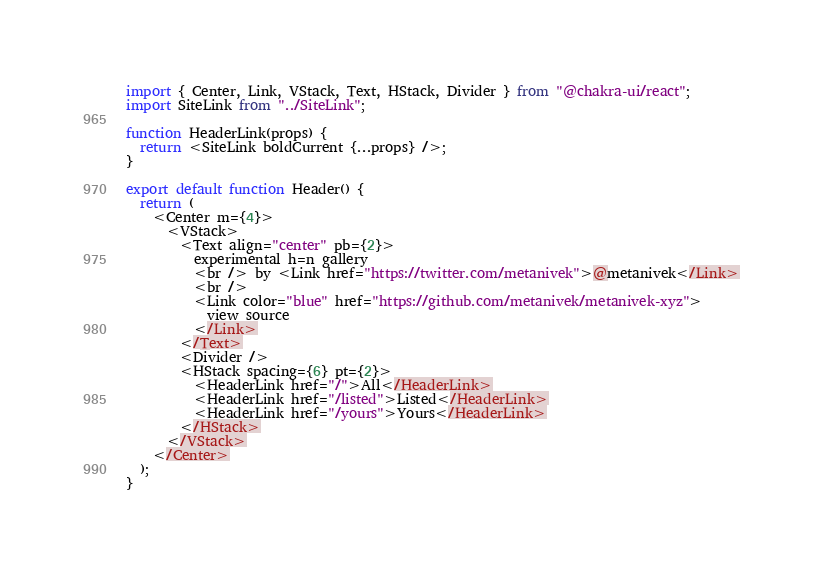Convert code to text. <code><loc_0><loc_0><loc_500><loc_500><_JavaScript_>import { Center, Link, VStack, Text, HStack, Divider } from "@chakra-ui/react";
import SiteLink from "../SiteLink";

function HeaderLink(props) {
  return <SiteLink boldCurrent {...props} />;
}

export default function Header() {
  return (
    <Center m={4}>
      <VStack>
        <Text align="center" pb={2}>
          experimental h=n gallery
          <br /> by <Link href="https://twitter.com/metanivek">@metanivek</Link>
          <br />
          <Link color="blue" href="https://github.com/metanivek/metanivek-xyz">
            view source
          </Link>
        </Text>
        <Divider />
        <HStack spacing={6} pt={2}>
          <HeaderLink href="/">All</HeaderLink>
          <HeaderLink href="/listed">Listed</HeaderLink>
          <HeaderLink href="/yours">Yours</HeaderLink>
        </HStack>
      </VStack>
    </Center>
  );
}
</code> 